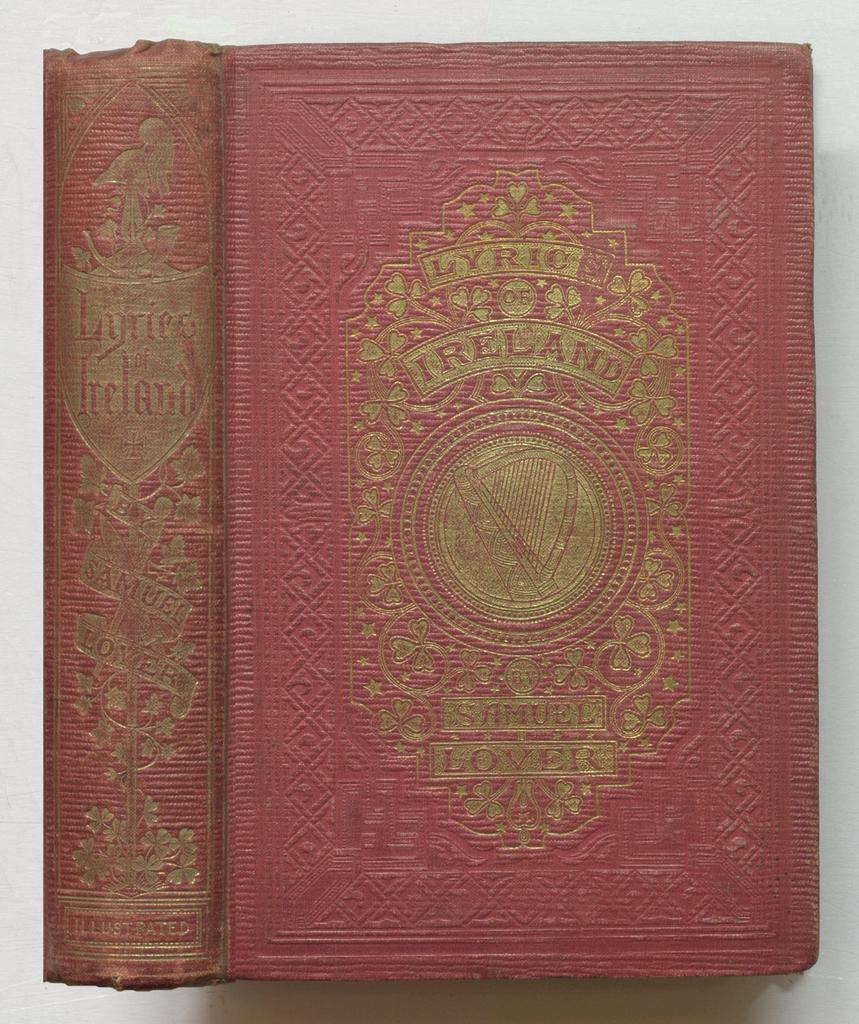<image>
Provide a brief description of the given image. A red book with a gold crest is titled Lyric of Ireland. 